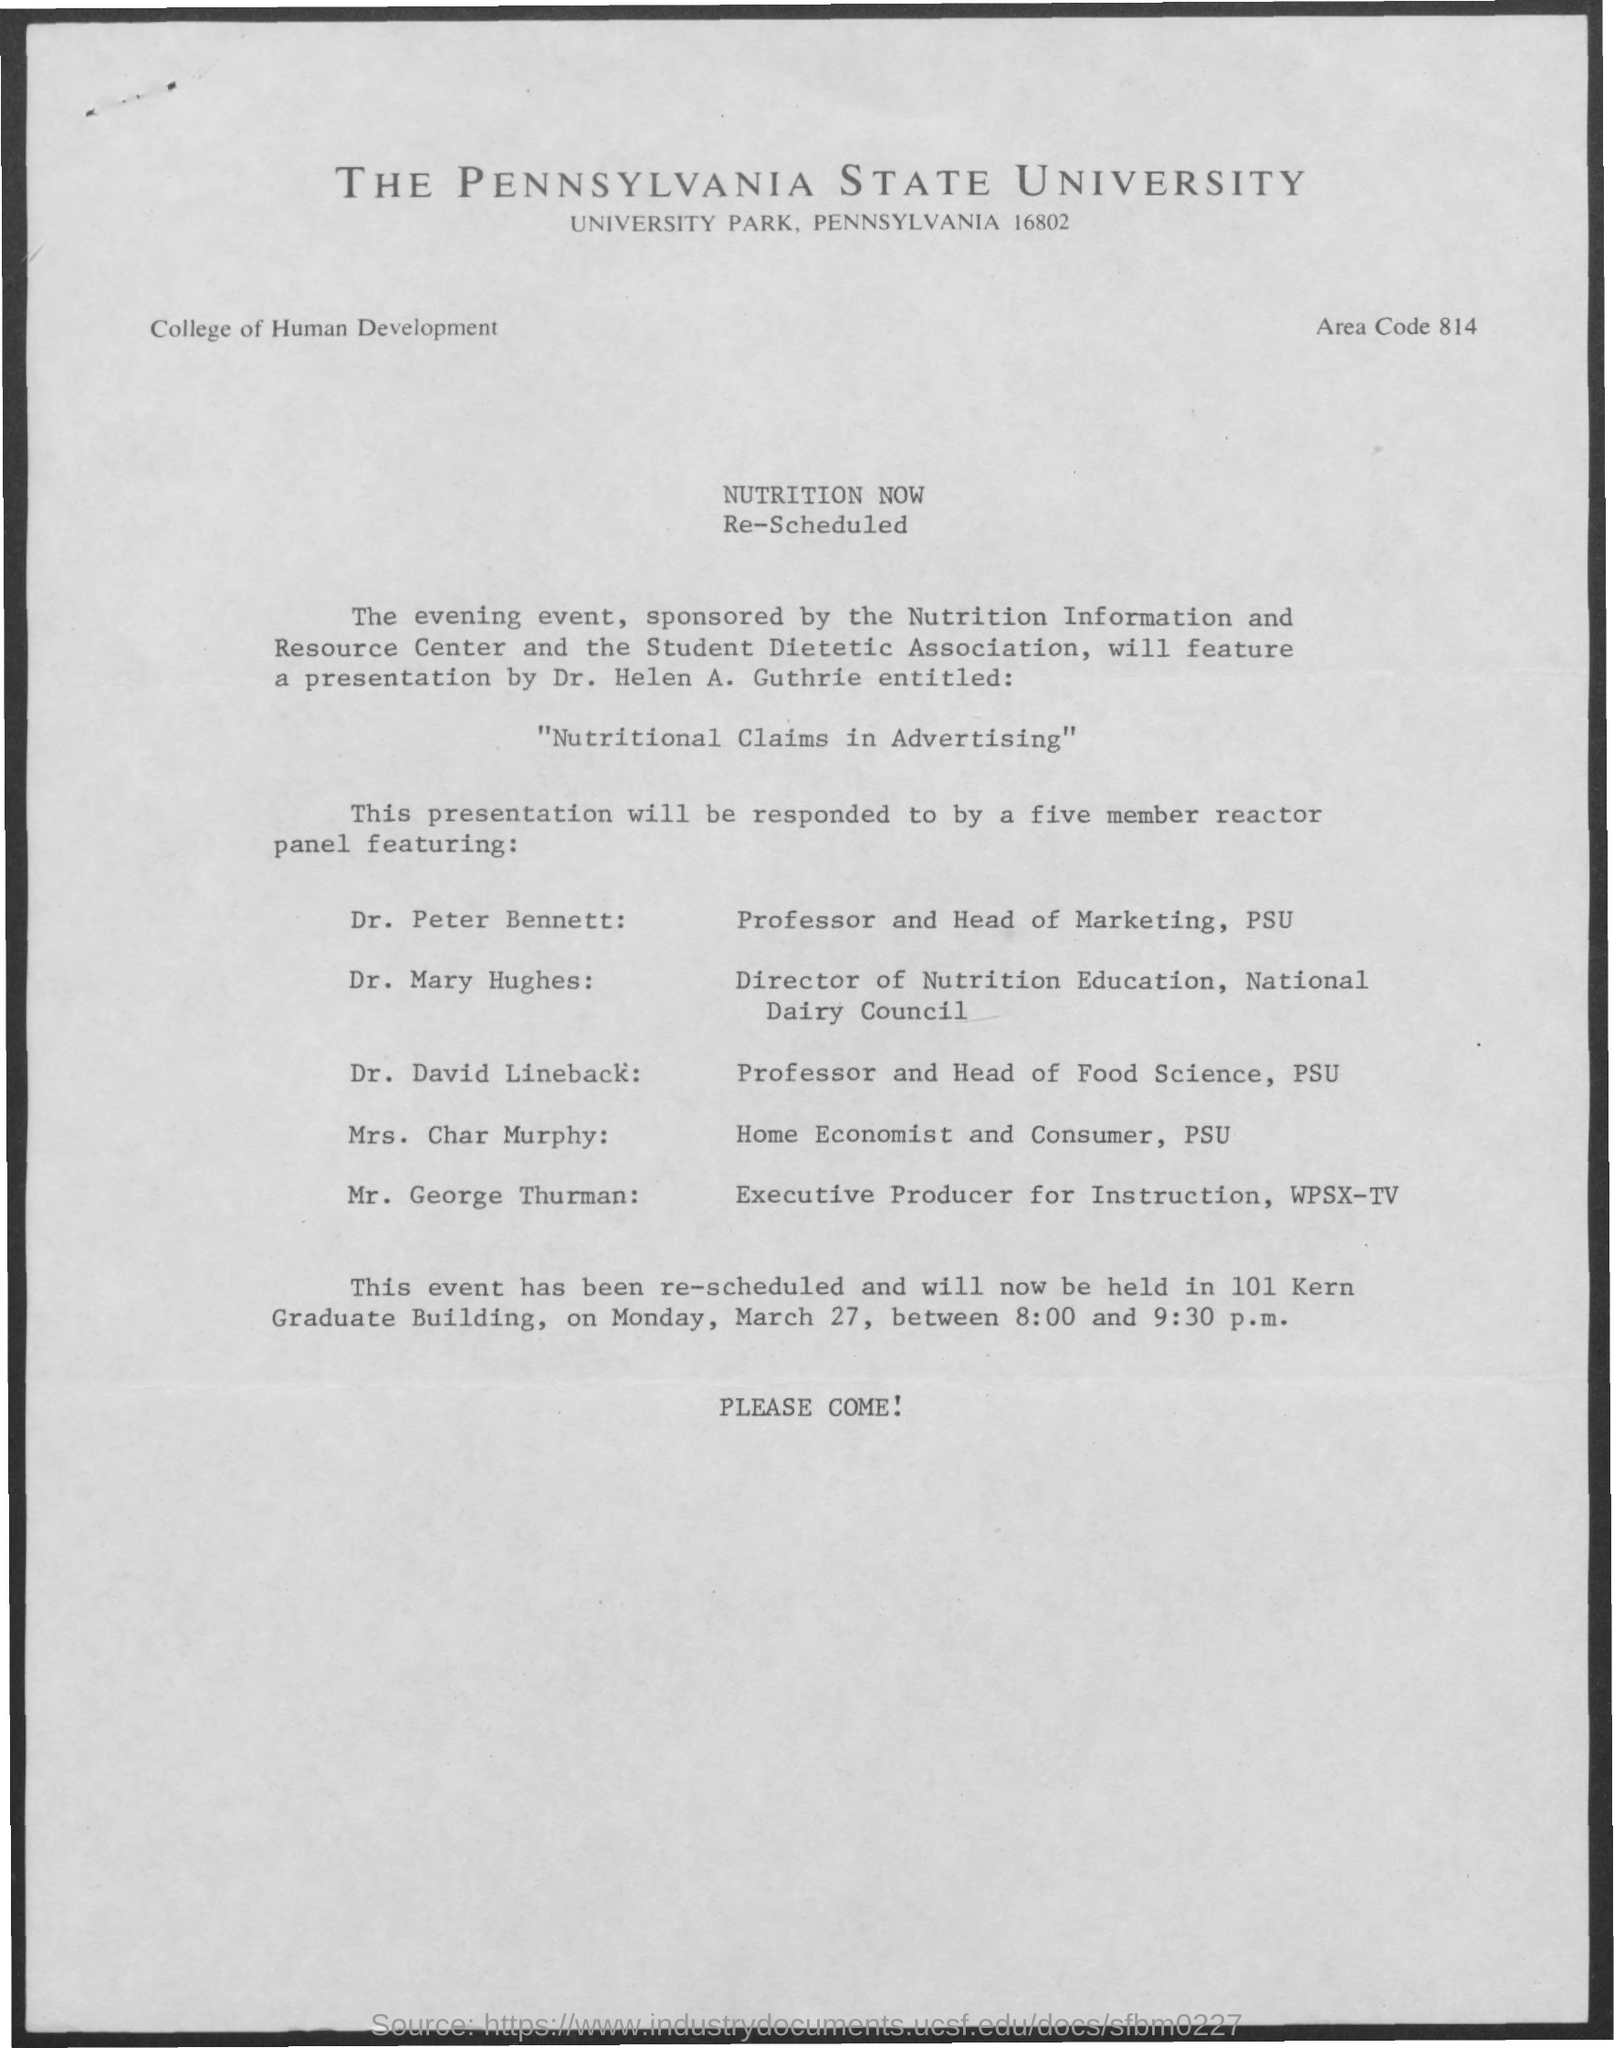What is the name of presentation given by Dr. Helen A.Guthrie?
Provide a succinct answer. "Nutritional Claims in Advertising". 